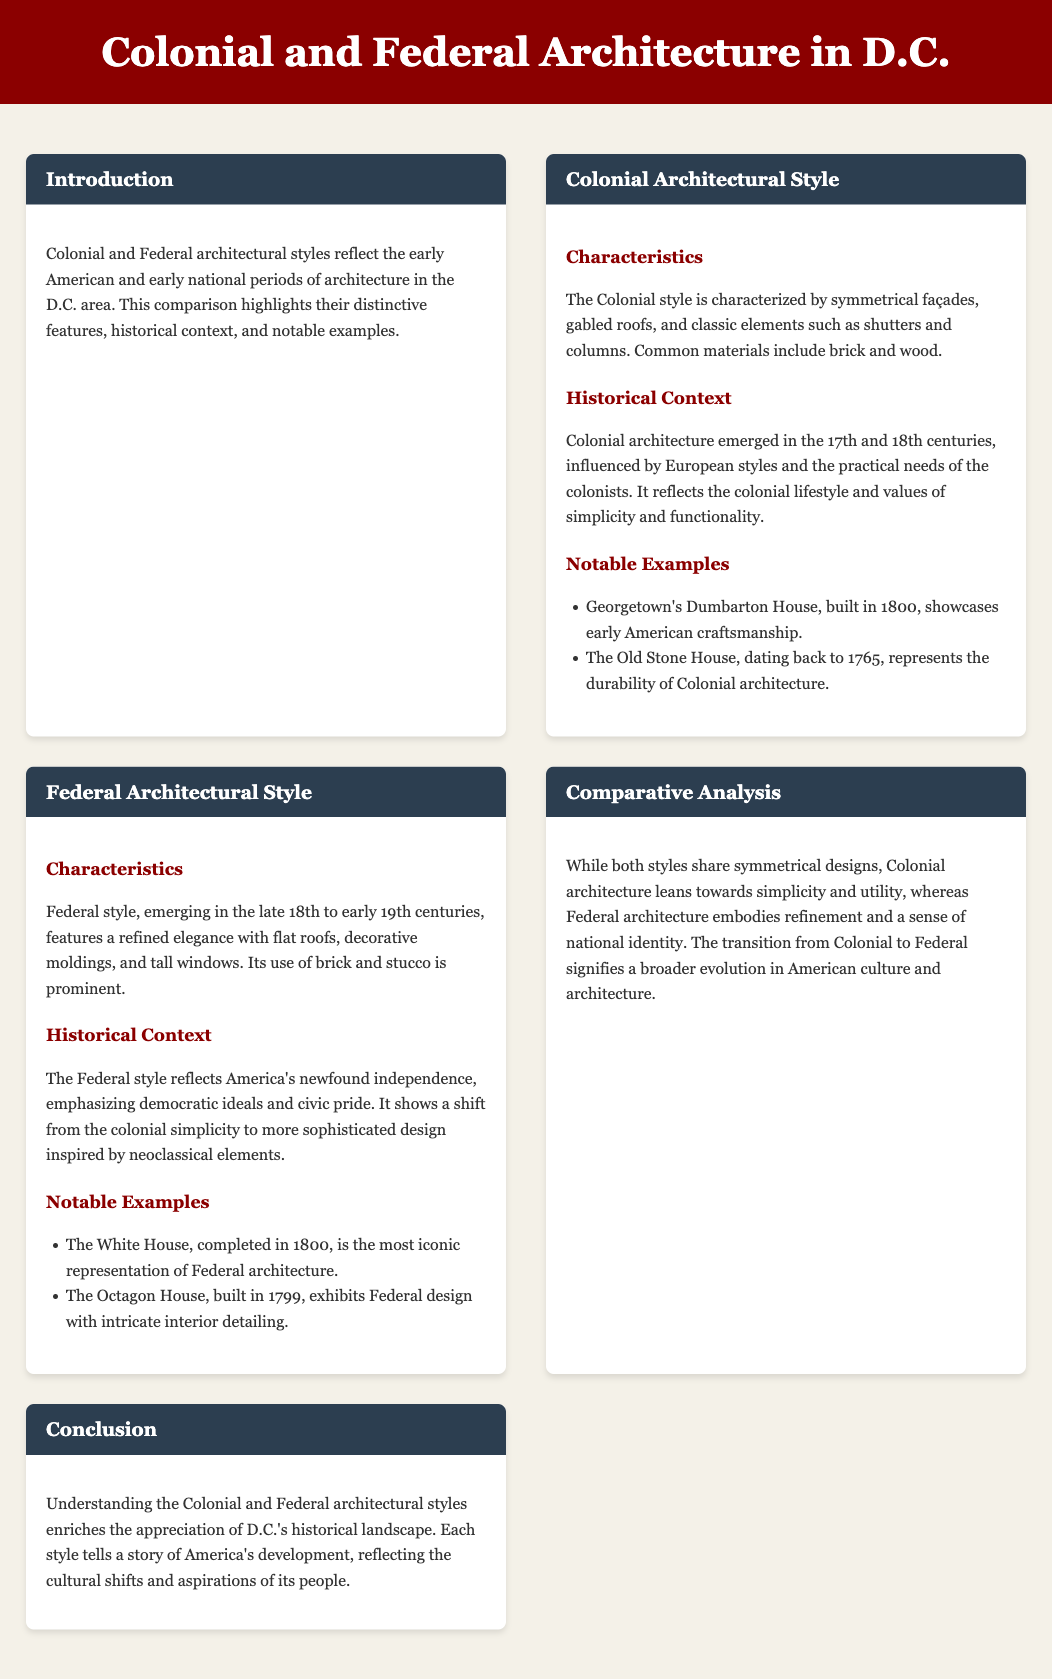What are the characteristics of Colonial architecture? The document states that Colonial style is characterized by symmetrical façades, gabled roofs, and classic elements such as shutters and columns.
Answer: Symmetrical façades, gabled roofs, shutters, columns When did Colonial architecture emerge? The document mentions that Colonial architecture emerged in the 17th and 18th centuries.
Answer: 17th and 18th centuries Name a notable example of Federal architecture. A notable example of Federal architecture provided in the document is The White House.
Answer: The White House What reflects America's newfound independence in architectural style? The document indicates that the Federal style reflects America's newfound independence and emphasizes democratic ideals and civic pride.
Answer: Federal style What is the main difference in design approach between Colonial and Federal architecture? The document explains that Colonial architecture leans towards simplicity and utility, while Federal architecture embodies refinement and national identity.
Answer: Simplicity vs. refinement Which style features flat roofs and decorative moldings? The document describes that the Federal style features a refined elegance with flat roofs and decorative moldings.
Answer: Federal style What year was the White House completed? According to the document, the White House was completed in 1800.
Answer: 1800 What element is commonly used in Colonial architecture? The document states that common materials in Colonial architecture include brick and wood.
Answer: Brick and wood 